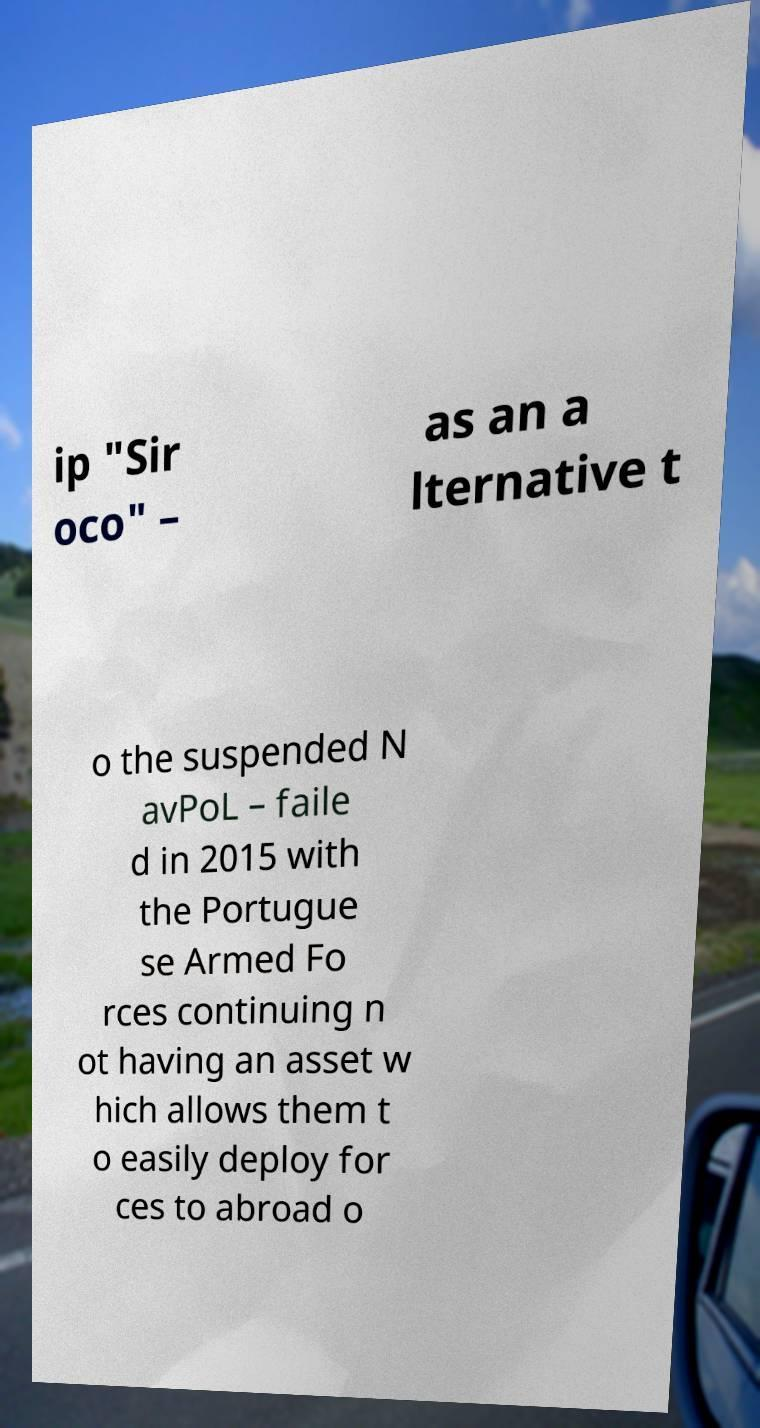There's text embedded in this image that I need extracted. Can you transcribe it verbatim? ip "Sir oco" – as an a lternative t o the suspended N avPoL – faile d in 2015 with the Portugue se Armed Fo rces continuing n ot having an asset w hich allows them t o easily deploy for ces to abroad o 